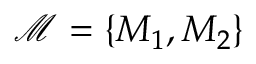<formula> <loc_0><loc_0><loc_500><loc_500>\mathcal { M } = \{ M _ { 1 } , M _ { 2 } \}</formula> 